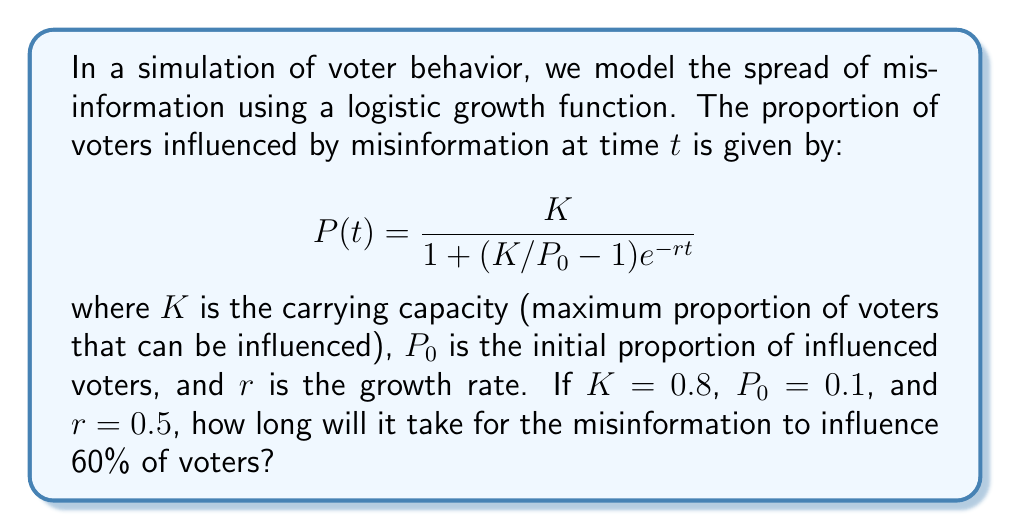Can you solve this math problem? To solve this problem, we need to follow these steps:

1) We are given:
   $K = 0.8$
   $P_0 = 0.1$
   $r = 0.5$
   
   We want to find $t$ when $P(t) = 0.6$

2) Substitute these values into the logistic growth equation:

   $$0.6 = \frac{0.8}{1 + (0.8/0.1 - 1)e^{-0.5t}}$$

3) Simplify:
   $$0.6 = \frac{0.8}{1 + 7e^{-0.5t}}$$

4) Multiply both sides by the denominator:
   $$0.6(1 + 7e^{-0.5t}) = 0.8$$

5) Expand:
   $$0.6 + 4.2e^{-0.5t} = 0.8$$

6) Subtract 0.6 from both sides:
   $$4.2e^{-0.5t} = 0.2$$

7) Divide both sides by 4.2:
   $$e^{-0.5t} = \frac{1}{21}$$

8) Take the natural log of both sides:
   $$-0.5t = \ln(\frac{1}{21})$$

9) Divide both sides by -0.5:
   $$t = -\frac{2}{1}\ln(\frac{1}{21}) = 2\ln(21)$$

10) Calculate the final value:
    $$t \approx 6.09$$

Therefore, it will take approximately 6.09 time units for the misinformation to influence 60% of voters.
Answer: $2\ln(21) \approx 6.09$ time units 